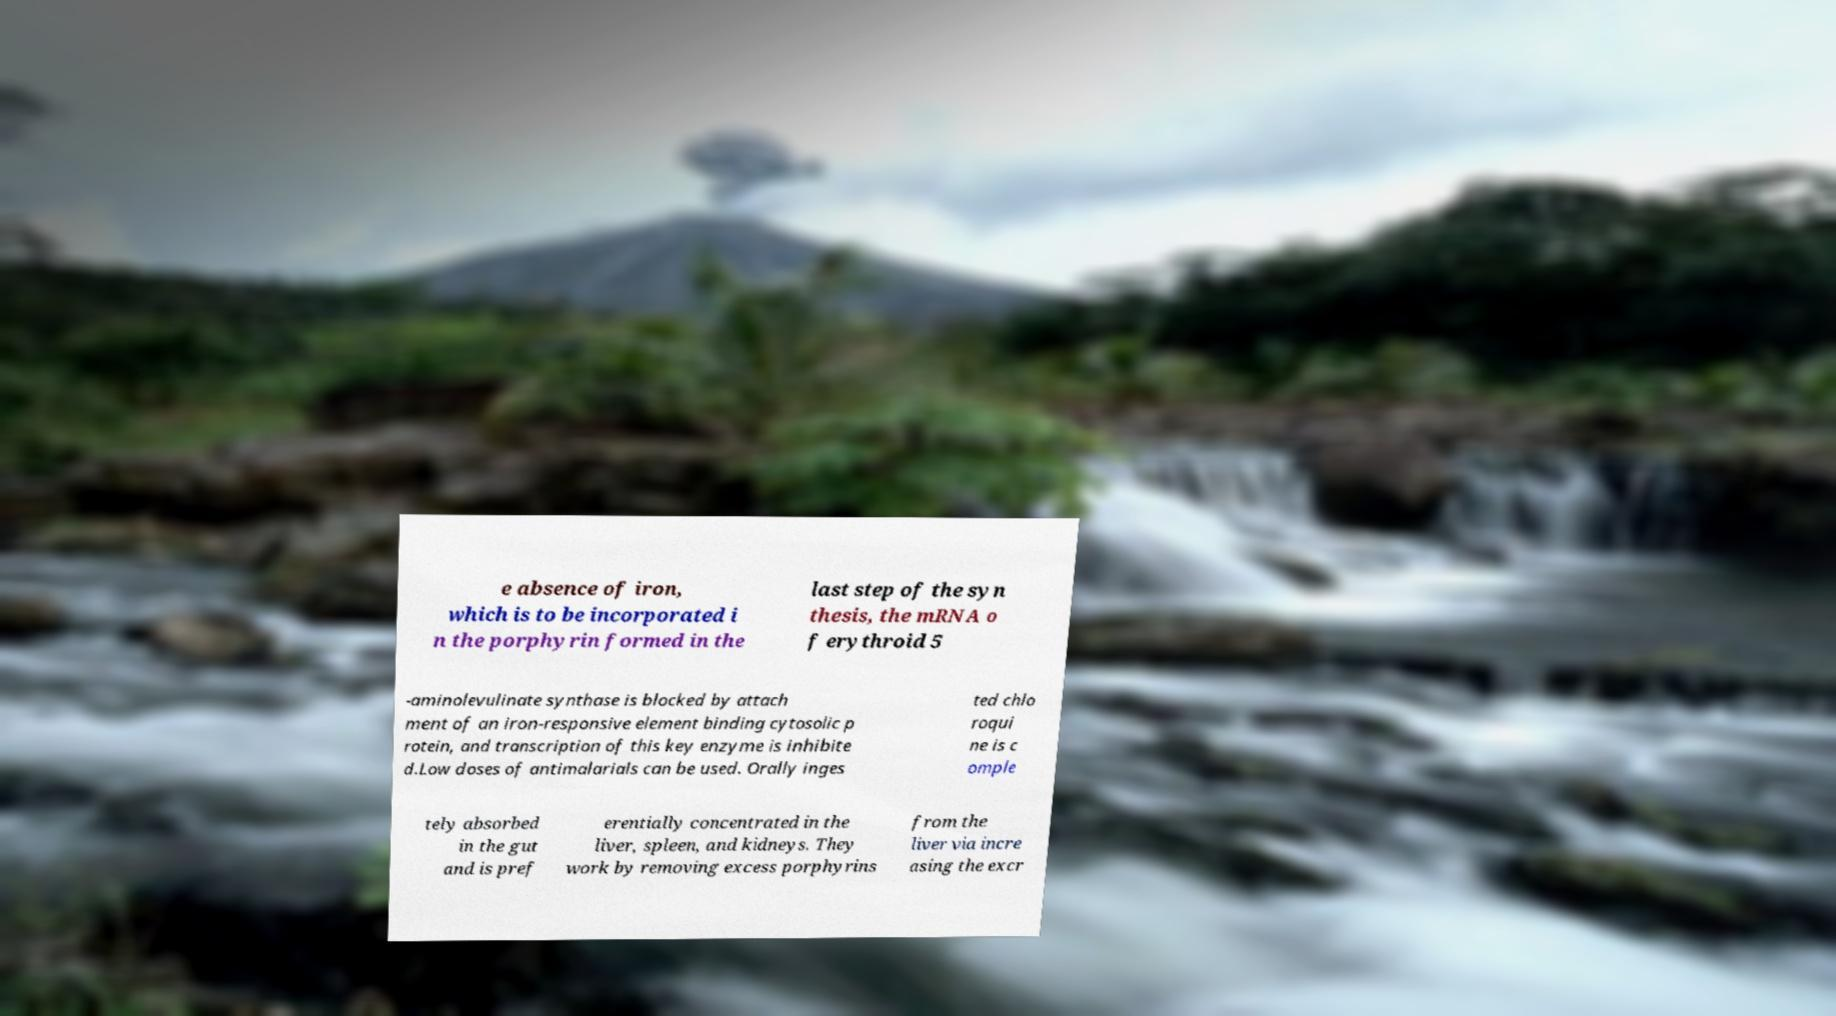I need the written content from this picture converted into text. Can you do that? e absence of iron, which is to be incorporated i n the porphyrin formed in the last step of the syn thesis, the mRNA o f erythroid 5 -aminolevulinate synthase is blocked by attach ment of an iron-responsive element binding cytosolic p rotein, and transcription of this key enzyme is inhibite d.Low doses of antimalarials can be used. Orally inges ted chlo roqui ne is c omple tely absorbed in the gut and is pref erentially concentrated in the liver, spleen, and kidneys. They work by removing excess porphyrins from the liver via incre asing the excr 